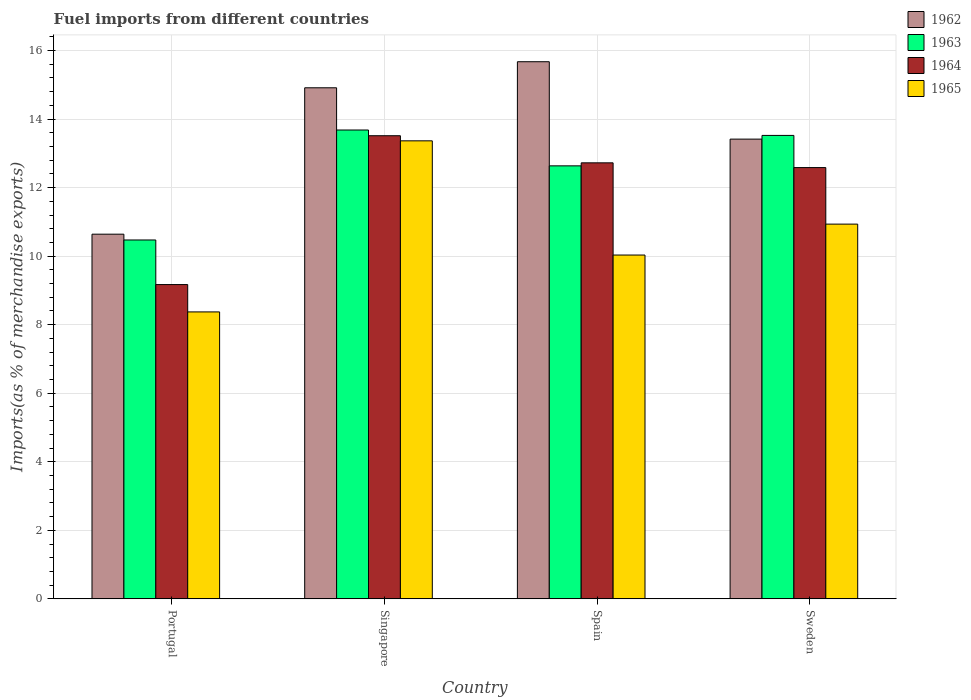How many different coloured bars are there?
Your answer should be very brief. 4. Are the number of bars per tick equal to the number of legend labels?
Your answer should be compact. Yes. Are the number of bars on each tick of the X-axis equal?
Provide a short and direct response. Yes. In how many cases, is the number of bars for a given country not equal to the number of legend labels?
Offer a very short reply. 0. What is the percentage of imports to different countries in 1964 in Singapore?
Give a very brief answer. 13.51. Across all countries, what is the maximum percentage of imports to different countries in 1964?
Make the answer very short. 13.51. Across all countries, what is the minimum percentage of imports to different countries in 1965?
Provide a short and direct response. 8.37. What is the total percentage of imports to different countries in 1962 in the graph?
Provide a short and direct response. 54.64. What is the difference between the percentage of imports to different countries in 1965 in Portugal and that in Spain?
Provide a succinct answer. -1.66. What is the difference between the percentage of imports to different countries in 1965 in Singapore and the percentage of imports to different countries in 1964 in Spain?
Provide a short and direct response. 0.64. What is the average percentage of imports to different countries in 1962 per country?
Make the answer very short. 13.66. What is the difference between the percentage of imports to different countries of/in 1963 and percentage of imports to different countries of/in 1962 in Sweden?
Offer a terse response. 0.11. In how many countries, is the percentage of imports to different countries in 1963 greater than 12.8 %?
Keep it short and to the point. 2. What is the ratio of the percentage of imports to different countries in 1963 in Portugal to that in Spain?
Provide a short and direct response. 0.83. What is the difference between the highest and the second highest percentage of imports to different countries in 1962?
Your response must be concise. -1.5. What is the difference between the highest and the lowest percentage of imports to different countries in 1962?
Provide a succinct answer. 5.03. Is the sum of the percentage of imports to different countries in 1965 in Portugal and Sweden greater than the maximum percentage of imports to different countries in 1964 across all countries?
Keep it short and to the point. Yes. Is it the case that in every country, the sum of the percentage of imports to different countries in 1964 and percentage of imports to different countries in 1962 is greater than the sum of percentage of imports to different countries in 1965 and percentage of imports to different countries in 1963?
Keep it short and to the point. No. What does the 1st bar from the left in Singapore represents?
Provide a succinct answer. 1962. What does the 1st bar from the right in Portugal represents?
Your answer should be compact. 1965. Is it the case that in every country, the sum of the percentage of imports to different countries in 1965 and percentage of imports to different countries in 1964 is greater than the percentage of imports to different countries in 1962?
Ensure brevity in your answer.  Yes. Are all the bars in the graph horizontal?
Offer a terse response. No. How many countries are there in the graph?
Keep it short and to the point. 4. What is the difference between two consecutive major ticks on the Y-axis?
Give a very brief answer. 2. Does the graph contain any zero values?
Your response must be concise. No. Does the graph contain grids?
Your response must be concise. Yes. Where does the legend appear in the graph?
Your response must be concise. Top right. How many legend labels are there?
Keep it short and to the point. 4. What is the title of the graph?
Make the answer very short. Fuel imports from different countries. What is the label or title of the X-axis?
Provide a short and direct response. Country. What is the label or title of the Y-axis?
Give a very brief answer. Imports(as % of merchandise exports). What is the Imports(as % of merchandise exports) of 1962 in Portugal?
Your answer should be compact. 10.64. What is the Imports(as % of merchandise exports) of 1963 in Portugal?
Give a very brief answer. 10.47. What is the Imports(as % of merchandise exports) in 1964 in Portugal?
Offer a very short reply. 9.17. What is the Imports(as % of merchandise exports) in 1965 in Portugal?
Your answer should be compact. 8.37. What is the Imports(as % of merchandise exports) in 1962 in Singapore?
Your answer should be compact. 14.91. What is the Imports(as % of merchandise exports) of 1963 in Singapore?
Provide a succinct answer. 13.68. What is the Imports(as % of merchandise exports) in 1964 in Singapore?
Offer a very short reply. 13.51. What is the Imports(as % of merchandise exports) in 1965 in Singapore?
Provide a succinct answer. 13.37. What is the Imports(as % of merchandise exports) of 1962 in Spain?
Ensure brevity in your answer.  15.67. What is the Imports(as % of merchandise exports) in 1963 in Spain?
Keep it short and to the point. 12.64. What is the Imports(as % of merchandise exports) of 1964 in Spain?
Provide a succinct answer. 12.72. What is the Imports(as % of merchandise exports) of 1965 in Spain?
Keep it short and to the point. 10.03. What is the Imports(as % of merchandise exports) of 1962 in Sweden?
Offer a very short reply. 13.42. What is the Imports(as % of merchandise exports) of 1963 in Sweden?
Give a very brief answer. 13.52. What is the Imports(as % of merchandise exports) of 1964 in Sweden?
Provide a succinct answer. 12.58. What is the Imports(as % of merchandise exports) of 1965 in Sweden?
Keep it short and to the point. 10.93. Across all countries, what is the maximum Imports(as % of merchandise exports) of 1962?
Provide a succinct answer. 15.67. Across all countries, what is the maximum Imports(as % of merchandise exports) of 1963?
Offer a very short reply. 13.68. Across all countries, what is the maximum Imports(as % of merchandise exports) in 1964?
Make the answer very short. 13.51. Across all countries, what is the maximum Imports(as % of merchandise exports) of 1965?
Offer a very short reply. 13.37. Across all countries, what is the minimum Imports(as % of merchandise exports) of 1962?
Provide a short and direct response. 10.64. Across all countries, what is the minimum Imports(as % of merchandise exports) of 1963?
Offer a terse response. 10.47. Across all countries, what is the minimum Imports(as % of merchandise exports) of 1964?
Offer a terse response. 9.17. Across all countries, what is the minimum Imports(as % of merchandise exports) in 1965?
Provide a short and direct response. 8.37. What is the total Imports(as % of merchandise exports) in 1962 in the graph?
Offer a terse response. 54.64. What is the total Imports(as % of merchandise exports) of 1963 in the graph?
Make the answer very short. 50.31. What is the total Imports(as % of merchandise exports) in 1964 in the graph?
Give a very brief answer. 47.99. What is the total Imports(as % of merchandise exports) in 1965 in the graph?
Offer a very short reply. 42.71. What is the difference between the Imports(as % of merchandise exports) of 1962 in Portugal and that in Singapore?
Offer a very short reply. -4.27. What is the difference between the Imports(as % of merchandise exports) of 1963 in Portugal and that in Singapore?
Make the answer very short. -3.21. What is the difference between the Imports(as % of merchandise exports) of 1964 in Portugal and that in Singapore?
Provide a short and direct response. -4.34. What is the difference between the Imports(as % of merchandise exports) of 1965 in Portugal and that in Singapore?
Ensure brevity in your answer.  -4.99. What is the difference between the Imports(as % of merchandise exports) in 1962 in Portugal and that in Spain?
Give a very brief answer. -5.03. What is the difference between the Imports(as % of merchandise exports) of 1963 in Portugal and that in Spain?
Your answer should be compact. -2.16. What is the difference between the Imports(as % of merchandise exports) of 1964 in Portugal and that in Spain?
Keep it short and to the point. -3.55. What is the difference between the Imports(as % of merchandise exports) in 1965 in Portugal and that in Spain?
Provide a succinct answer. -1.66. What is the difference between the Imports(as % of merchandise exports) of 1962 in Portugal and that in Sweden?
Your response must be concise. -2.77. What is the difference between the Imports(as % of merchandise exports) in 1963 in Portugal and that in Sweden?
Offer a terse response. -3.05. What is the difference between the Imports(as % of merchandise exports) of 1964 in Portugal and that in Sweden?
Offer a terse response. -3.41. What is the difference between the Imports(as % of merchandise exports) in 1965 in Portugal and that in Sweden?
Provide a succinct answer. -2.56. What is the difference between the Imports(as % of merchandise exports) in 1962 in Singapore and that in Spain?
Ensure brevity in your answer.  -0.76. What is the difference between the Imports(as % of merchandise exports) in 1963 in Singapore and that in Spain?
Your answer should be compact. 1.05. What is the difference between the Imports(as % of merchandise exports) in 1964 in Singapore and that in Spain?
Provide a short and direct response. 0.79. What is the difference between the Imports(as % of merchandise exports) in 1965 in Singapore and that in Spain?
Provide a succinct answer. 3.33. What is the difference between the Imports(as % of merchandise exports) of 1962 in Singapore and that in Sweden?
Your answer should be compact. 1.5. What is the difference between the Imports(as % of merchandise exports) in 1963 in Singapore and that in Sweden?
Ensure brevity in your answer.  0.16. What is the difference between the Imports(as % of merchandise exports) in 1964 in Singapore and that in Sweden?
Offer a very short reply. 0.93. What is the difference between the Imports(as % of merchandise exports) in 1965 in Singapore and that in Sweden?
Give a very brief answer. 2.43. What is the difference between the Imports(as % of merchandise exports) in 1962 in Spain and that in Sweden?
Make the answer very short. 2.26. What is the difference between the Imports(as % of merchandise exports) of 1963 in Spain and that in Sweden?
Offer a very short reply. -0.89. What is the difference between the Imports(as % of merchandise exports) of 1964 in Spain and that in Sweden?
Your answer should be very brief. 0.14. What is the difference between the Imports(as % of merchandise exports) of 1965 in Spain and that in Sweden?
Offer a very short reply. -0.9. What is the difference between the Imports(as % of merchandise exports) in 1962 in Portugal and the Imports(as % of merchandise exports) in 1963 in Singapore?
Your response must be concise. -3.04. What is the difference between the Imports(as % of merchandise exports) of 1962 in Portugal and the Imports(as % of merchandise exports) of 1964 in Singapore?
Provide a succinct answer. -2.87. What is the difference between the Imports(as % of merchandise exports) in 1962 in Portugal and the Imports(as % of merchandise exports) in 1965 in Singapore?
Offer a terse response. -2.72. What is the difference between the Imports(as % of merchandise exports) of 1963 in Portugal and the Imports(as % of merchandise exports) of 1964 in Singapore?
Provide a succinct answer. -3.04. What is the difference between the Imports(as % of merchandise exports) in 1963 in Portugal and the Imports(as % of merchandise exports) in 1965 in Singapore?
Make the answer very short. -2.89. What is the difference between the Imports(as % of merchandise exports) in 1964 in Portugal and the Imports(as % of merchandise exports) in 1965 in Singapore?
Offer a terse response. -4.19. What is the difference between the Imports(as % of merchandise exports) of 1962 in Portugal and the Imports(as % of merchandise exports) of 1963 in Spain?
Keep it short and to the point. -1.99. What is the difference between the Imports(as % of merchandise exports) of 1962 in Portugal and the Imports(as % of merchandise exports) of 1964 in Spain?
Give a very brief answer. -2.08. What is the difference between the Imports(as % of merchandise exports) of 1962 in Portugal and the Imports(as % of merchandise exports) of 1965 in Spain?
Keep it short and to the point. 0.61. What is the difference between the Imports(as % of merchandise exports) in 1963 in Portugal and the Imports(as % of merchandise exports) in 1964 in Spain?
Offer a very short reply. -2.25. What is the difference between the Imports(as % of merchandise exports) of 1963 in Portugal and the Imports(as % of merchandise exports) of 1965 in Spain?
Your answer should be compact. 0.44. What is the difference between the Imports(as % of merchandise exports) in 1964 in Portugal and the Imports(as % of merchandise exports) in 1965 in Spain?
Keep it short and to the point. -0.86. What is the difference between the Imports(as % of merchandise exports) of 1962 in Portugal and the Imports(as % of merchandise exports) of 1963 in Sweden?
Provide a short and direct response. -2.88. What is the difference between the Imports(as % of merchandise exports) in 1962 in Portugal and the Imports(as % of merchandise exports) in 1964 in Sweden?
Provide a short and direct response. -1.94. What is the difference between the Imports(as % of merchandise exports) of 1962 in Portugal and the Imports(as % of merchandise exports) of 1965 in Sweden?
Give a very brief answer. -0.29. What is the difference between the Imports(as % of merchandise exports) in 1963 in Portugal and the Imports(as % of merchandise exports) in 1964 in Sweden?
Make the answer very short. -2.11. What is the difference between the Imports(as % of merchandise exports) in 1963 in Portugal and the Imports(as % of merchandise exports) in 1965 in Sweden?
Your answer should be very brief. -0.46. What is the difference between the Imports(as % of merchandise exports) of 1964 in Portugal and the Imports(as % of merchandise exports) of 1965 in Sweden?
Your response must be concise. -1.76. What is the difference between the Imports(as % of merchandise exports) of 1962 in Singapore and the Imports(as % of merchandise exports) of 1963 in Spain?
Give a very brief answer. 2.28. What is the difference between the Imports(as % of merchandise exports) in 1962 in Singapore and the Imports(as % of merchandise exports) in 1964 in Spain?
Your answer should be very brief. 2.19. What is the difference between the Imports(as % of merchandise exports) of 1962 in Singapore and the Imports(as % of merchandise exports) of 1965 in Spain?
Provide a short and direct response. 4.88. What is the difference between the Imports(as % of merchandise exports) of 1963 in Singapore and the Imports(as % of merchandise exports) of 1964 in Spain?
Your response must be concise. 0.96. What is the difference between the Imports(as % of merchandise exports) in 1963 in Singapore and the Imports(as % of merchandise exports) in 1965 in Spain?
Make the answer very short. 3.65. What is the difference between the Imports(as % of merchandise exports) in 1964 in Singapore and the Imports(as % of merchandise exports) in 1965 in Spain?
Your response must be concise. 3.48. What is the difference between the Imports(as % of merchandise exports) in 1962 in Singapore and the Imports(as % of merchandise exports) in 1963 in Sweden?
Offer a terse response. 1.39. What is the difference between the Imports(as % of merchandise exports) in 1962 in Singapore and the Imports(as % of merchandise exports) in 1964 in Sweden?
Your response must be concise. 2.33. What is the difference between the Imports(as % of merchandise exports) in 1962 in Singapore and the Imports(as % of merchandise exports) in 1965 in Sweden?
Your answer should be compact. 3.98. What is the difference between the Imports(as % of merchandise exports) in 1963 in Singapore and the Imports(as % of merchandise exports) in 1964 in Sweden?
Ensure brevity in your answer.  1.1. What is the difference between the Imports(as % of merchandise exports) of 1963 in Singapore and the Imports(as % of merchandise exports) of 1965 in Sweden?
Your answer should be compact. 2.75. What is the difference between the Imports(as % of merchandise exports) of 1964 in Singapore and the Imports(as % of merchandise exports) of 1965 in Sweden?
Offer a very short reply. 2.58. What is the difference between the Imports(as % of merchandise exports) of 1962 in Spain and the Imports(as % of merchandise exports) of 1963 in Sweden?
Keep it short and to the point. 2.15. What is the difference between the Imports(as % of merchandise exports) in 1962 in Spain and the Imports(as % of merchandise exports) in 1964 in Sweden?
Provide a succinct answer. 3.09. What is the difference between the Imports(as % of merchandise exports) in 1962 in Spain and the Imports(as % of merchandise exports) in 1965 in Sweden?
Make the answer very short. 4.74. What is the difference between the Imports(as % of merchandise exports) in 1963 in Spain and the Imports(as % of merchandise exports) in 1964 in Sweden?
Give a very brief answer. 0.05. What is the difference between the Imports(as % of merchandise exports) of 1963 in Spain and the Imports(as % of merchandise exports) of 1965 in Sweden?
Offer a terse response. 1.7. What is the difference between the Imports(as % of merchandise exports) in 1964 in Spain and the Imports(as % of merchandise exports) in 1965 in Sweden?
Offer a terse response. 1.79. What is the average Imports(as % of merchandise exports) in 1962 per country?
Your response must be concise. 13.66. What is the average Imports(as % of merchandise exports) in 1963 per country?
Offer a terse response. 12.58. What is the average Imports(as % of merchandise exports) of 1964 per country?
Offer a very short reply. 12. What is the average Imports(as % of merchandise exports) of 1965 per country?
Provide a succinct answer. 10.68. What is the difference between the Imports(as % of merchandise exports) in 1962 and Imports(as % of merchandise exports) in 1963 in Portugal?
Provide a short and direct response. 0.17. What is the difference between the Imports(as % of merchandise exports) in 1962 and Imports(as % of merchandise exports) in 1964 in Portugal?
Your answer should be very brief. 1.47. What is the difference between the Imports(as % of merchandise exports) of 1962 and Imports(as % of merchandise exports) of 1965 in Portugal?
Provide a succinct answer. 2.27. What is the difference between the Imports(as % of merchandise exports) in 1963 and Imports(as % of merchandise exports) in 1964 in Portugal?
Make the answer very short. 1.3. What is the difference between the Imports(as % of merchandise exports) of 1963 and Imports(as % of merchandise exports) of 1965 in Portugal?
Provide a succinct answer. 2.1. What is the difference between the Imports(as % of merchandise exports) of 1964 and Imports(as % of merchandise exports) of 1965 in Portugal?
Make the answer very short. 0.8. What is the difference between the Imports(as % of merchandise exports) of 1962 and Imports(as % of merchandise exports) of 1963 in Singapore?
Provide a succinct answer. 1.23. What is the difference between the Imports(as % of merchandise exports) in 1962 and Imports(as % of merchandise exports) in 1964 in Singapore?
Offer a very short reply. 1.4. What is the difference between the Imports(as % of merchandise exports) in 1962 and Imports(as % of merchandise exports) in 1965 in Singapore?
Your response must be concise. 1.55. What is the difference between the Imports(as % of merchandise exports) of 1963 and Imports(as % of merchandise exports) of 1964 in Singapore?
Provide a short and direct response. 0.17. What is the difference between the Imports(as % of merchandise exports) in 1963 and Imports(as % of merchandise exports) in 1965 in Singapore?
Keep it short and to the point. 0.32. What is the difference between the Imports(as % of merchandise exports) of 1964 and Imports(as % of merchandise exports) of 1965 in Singapore?
Provide a succinct answer. 0.15. What is the difference between the Imports(as % of merchandise exports) of 1962 and Imports(as % of merchandise exports) of 1963 in Spain?
Offer a very short reply. 3.04. What is the difference between the Imports(as % of merchandise exports) in 1962 and Imports(as % of merchandise exports) in 1964 in Spain?
Ensure brevity in your answer.  2.95. What is the difference between the Imports(as % of merchandise exports) in 1962 and Imports(as % of merchandise exports) in 1965 in Spain?
Provide a short and direct response. 5.64. What is the difference between the Imports(as % of merchandise exports) in 1963 and Imports(as % of merchandise exports) in 1964 in Spain?
Provide a short and direct response. -0.09. What is the difference between the Imports(as % of merchandise exports) of 1963 and Imports(as % of merchandise exports) of 1965 in Spain?
Your answer should be very brief. 2.6. What is the difference between the Imports(as % of merchandise exports) of 1964 and Imports(as % of merchandise exports) of 1965 in Spain?
Provide a short and direct response. 2.69. What is the difference between the Imports(as % of merchandise exports) of 1962 and Imports(as % of merchandise exports) of 1963 in Sweden?
Ensure brevity in your answer.  -0.11. What is the difference between the Imports(as % of merchandise exports) in 1962 and Imports(as % of merchandise exports) in 1964 in Sweden?
Give a very brief answer. 0.83. What is the difference between the Imports(as % of merchandise exports) of 1962 and Imports(as % of merchandise exports) of 1965 in Sweden?
Your answer should be very brief. 2.48. What is the difference between the Imports(as % of merchandise exports) of 1963 and Imports(as % of merchandise exports) of 1964 in Sweden?
Make the answer very short. 0.94. What is the difference between the Imports(as % of merchandise exports) in 1963 and Imports(as % of merchandise exports) in 1965 in Sweden?
Ensure brevity in your answer.  2.59. What is the difference between the Imports(as % of merchandise exports) in 1964 and Imports(as % of merchandise exports) in 1965 in Sweden?
Your response must be concise. 1.65. What is the ratio of the Imports(as % of merchandise exports) of 1962 in Portugal to that in Singapore?
Your answer should be very brief. 0.71. What is the ratio of the Imports(as % of merchandise exports) of 1963 in Portugal to that in Singapore?
Keep it short and to the point. 0.77. What is the ratio of the Imports(as % of merchandise exports) in 1964 in Portugal to that in Singapore?
Your answer should be compact. 0.68. What is the ratio of the Imports(as % of merchandise exports) of 1965 in Portugal to that in Singapore?
Offer a very short reply. 0.63. What is the ratio of the Imports(as % of merchandise exports) of 1962 in Portugal to that in Spain?
Your answer should be very brief. 0.68. What is the ratio of the Imports(as % of merchandise exports) in 1963 in Portugal to that in Spain?
Offer a terse response. 0.83. What is the ratio of the Imports(as % of merchandise exports) in 1964 in Portugal to that in Spain?
Your answer should be compact. 0.72. What is the ratio of the Imports(as % of merchandise exports) of 1965 in Portugal to that in Spain?
Provide a short and direct response. 0.83. What is the ratio of the Imports(as % of merchandise exports) of 1962 in Portugal to that in Sweden?
Your answer should be very brief. 0.79. What is the ratio of the Imports(as % of merchandise exports) in 1963 in Portugal to that in Sweden?
Give a very brief answer. 0.77. What is the ratio of the Imports(as % of merchandise exports) in 1964 in Portugal to that in Sweden?
Your response must be concise. 0.73. What is the ratio of the Imports(as % of merchandise exports) of 1965 in Portugal to that in Sweden?
Keep it short and to the point. 0.77. What is the ratio of the Imports(as % of merchandise exports) of 1962 in Singapore to that in Spain?
Your answer should be compact. 0.95. What is the ratio of the Imports(as % of merchandise exports) of 1963 in Singapore to that in Spain?
Make the answer very short. 1.08. What is the ratio of the Imports(as % of merchandise exports) of 1964 in Singapore to that in Spain?
Give a very brief answer. 1.06. What is the ratio of the Imports(as % of merchandise exports) in 1965 in Singapore to that in Spain?
Your response must be concise. 1.33. What is the ratio of the Imports(as % of merchandise exports) in 1962 in Singapore to that in Sweden?
Your response must be concise. 1.11. What is the ratio of the Imports(as % of merchandise exports) of 1963 in Singapore to that in Sweden?
Give a very brief answer. 1.01. What is the ratio of the Imports(as % of merchandise exports) of 1964 in Singapore to that in Sweden?
Your response must be concise. 1.07. What is the ratio of the Imports(as % of merchandise exports) in 1965 in Singapore to that in Sweden?
Keep it short and to the point. 1.22. What is the ratio of the Imports(as % of merchandise exports) in 1962 in Spain to that in Sweden?
Your answer should be compact. 1.17. What is the ratio of the Imports(as % of merchandise exports) in 1963 in Spain to that in Sweden?
Your answer should be compact. 0.93. What is the ratio of the Imports(as % of merchandise exports) in 1964 in Spain to that in Sweden?
Offer a terse response. 1.01. What is the ratio of the Imports(as % of merchandise exports) of 1965 in Spain to that in Sweden?
Make the answer very short. 0.92. What is the difference between the highest and the second highest Imports(as % of merchandise exports) of 1962?
Your response must be concise. 0.76. What is the difference between the highest and the second highest Imports(as % of merchandise exports) of 1963?
Your answer should be compact. 0.16. What is the difference between the highest and the second highest Imports(as % of merchandise exports) in 1964?
Give a very brief answer. 0.79. What is the difference between the highest and the second highest Imports(as % of merchandise exports) of 1965?
Your answer should be compact. 2.43. What is the difference between the highest and the lowest Imports(as % of merchandise exports) of 1962?
Offer a very short reply. 5.03. What is the difference between the highest and the lowest Imports(as % of merchandise exports) in 1963?
Your response must be concise. 3.21. What is the difference between the highest and the lowest Imports(as % of merchandise exports) of 1964?
Offer a very short reply. 4.34. What is the difference between the highest and the lowest Imports(as % of merchandise exports) of 1965?
Offer a terse response. 4.99. 